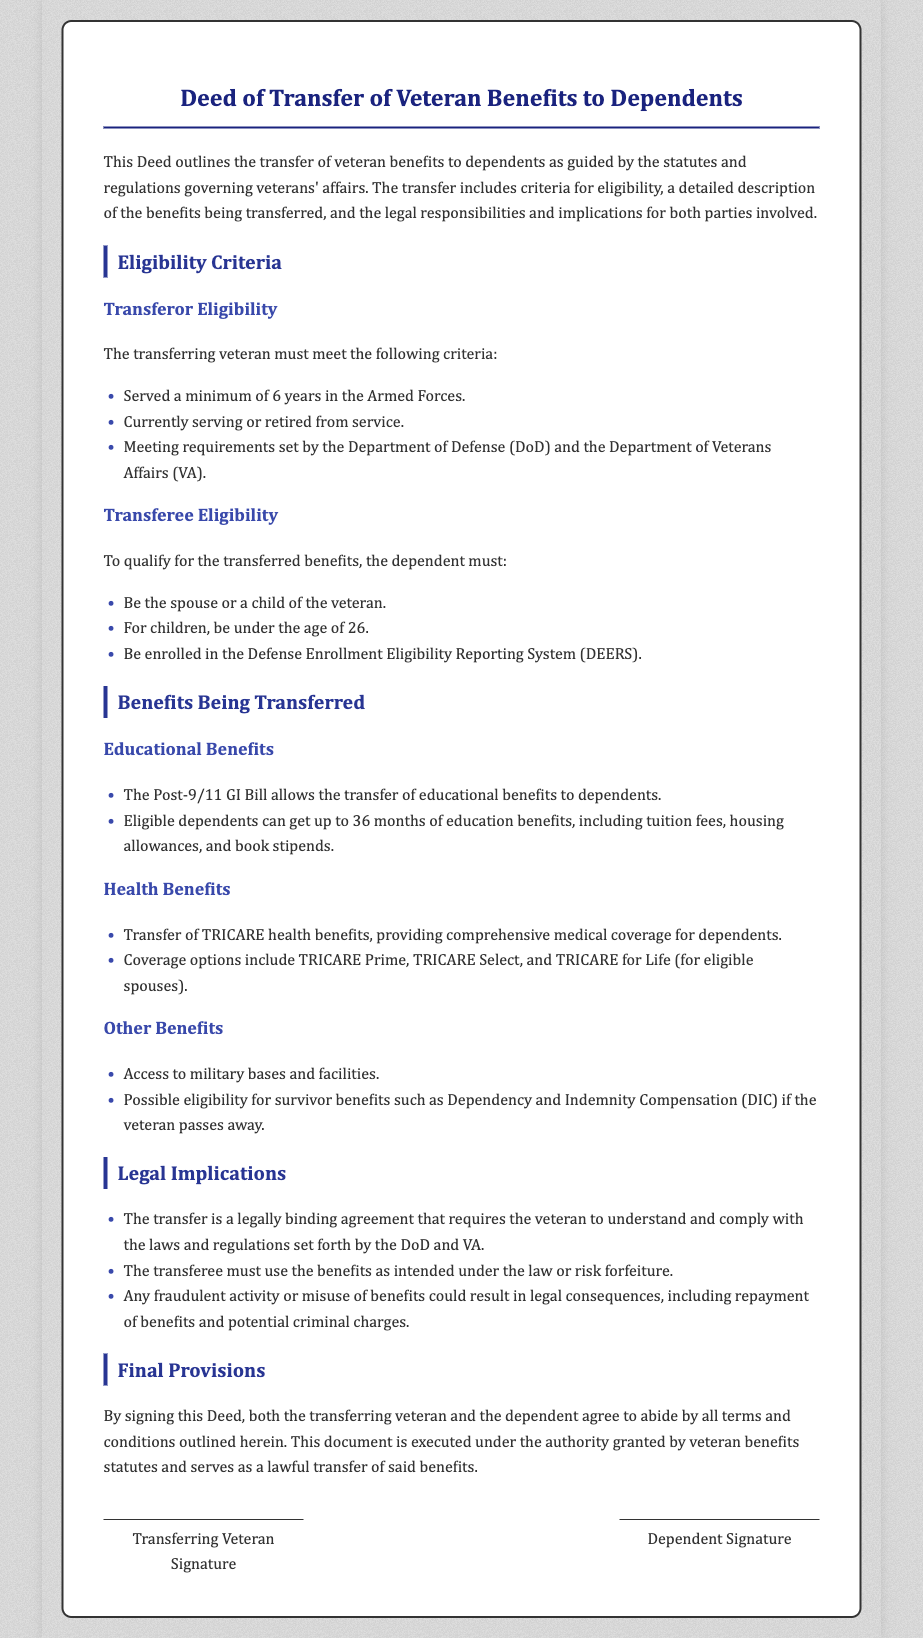What is the minimum service requirement for the transferring veteran? The document states that the transferring veteran must have served a minimum of 6 years in the Armed Forces.
Answer: 6 years Who must the dependent be in order to qualify for the transferred benefits? The document specifies that the dependent must be the spouse or a child of the veteran.
Answer: spouse or child What is the age limit for children to receive transferred benefits? According to the eligibility criteria, children must be under the age of 26 to qualify for the transferred benefits.
Answer: under the age of 26 What educational benefit can be transferred to dependents? The document refers to the Post-9/11 GI Bill as the educational benefit that can be transferred to dependents.
Answer: Post-9/11 GI Bill What medical coverage is mentioned in relation to health benefits? The document outlines that TRICARE health benefits provide comprehensive medical coverage for dependents.
Answer: TRICARE What must transferees do to avoid forfeiture of benefits? The document indicates that the transferee must use the benefits as intended under the law to avoid forfeiture.
Answer: Use as intended What does the Deed serve as when signed? Upon signing, the Deed serves as a lawful transfer of veteran benefits.
Answer: Lawful transfer What could result from fraudulent activity regarding the benefits? The document notes that fraudulent activity could lead to legal consequences, including repayment of benefits.
Answer: Legal consequences 